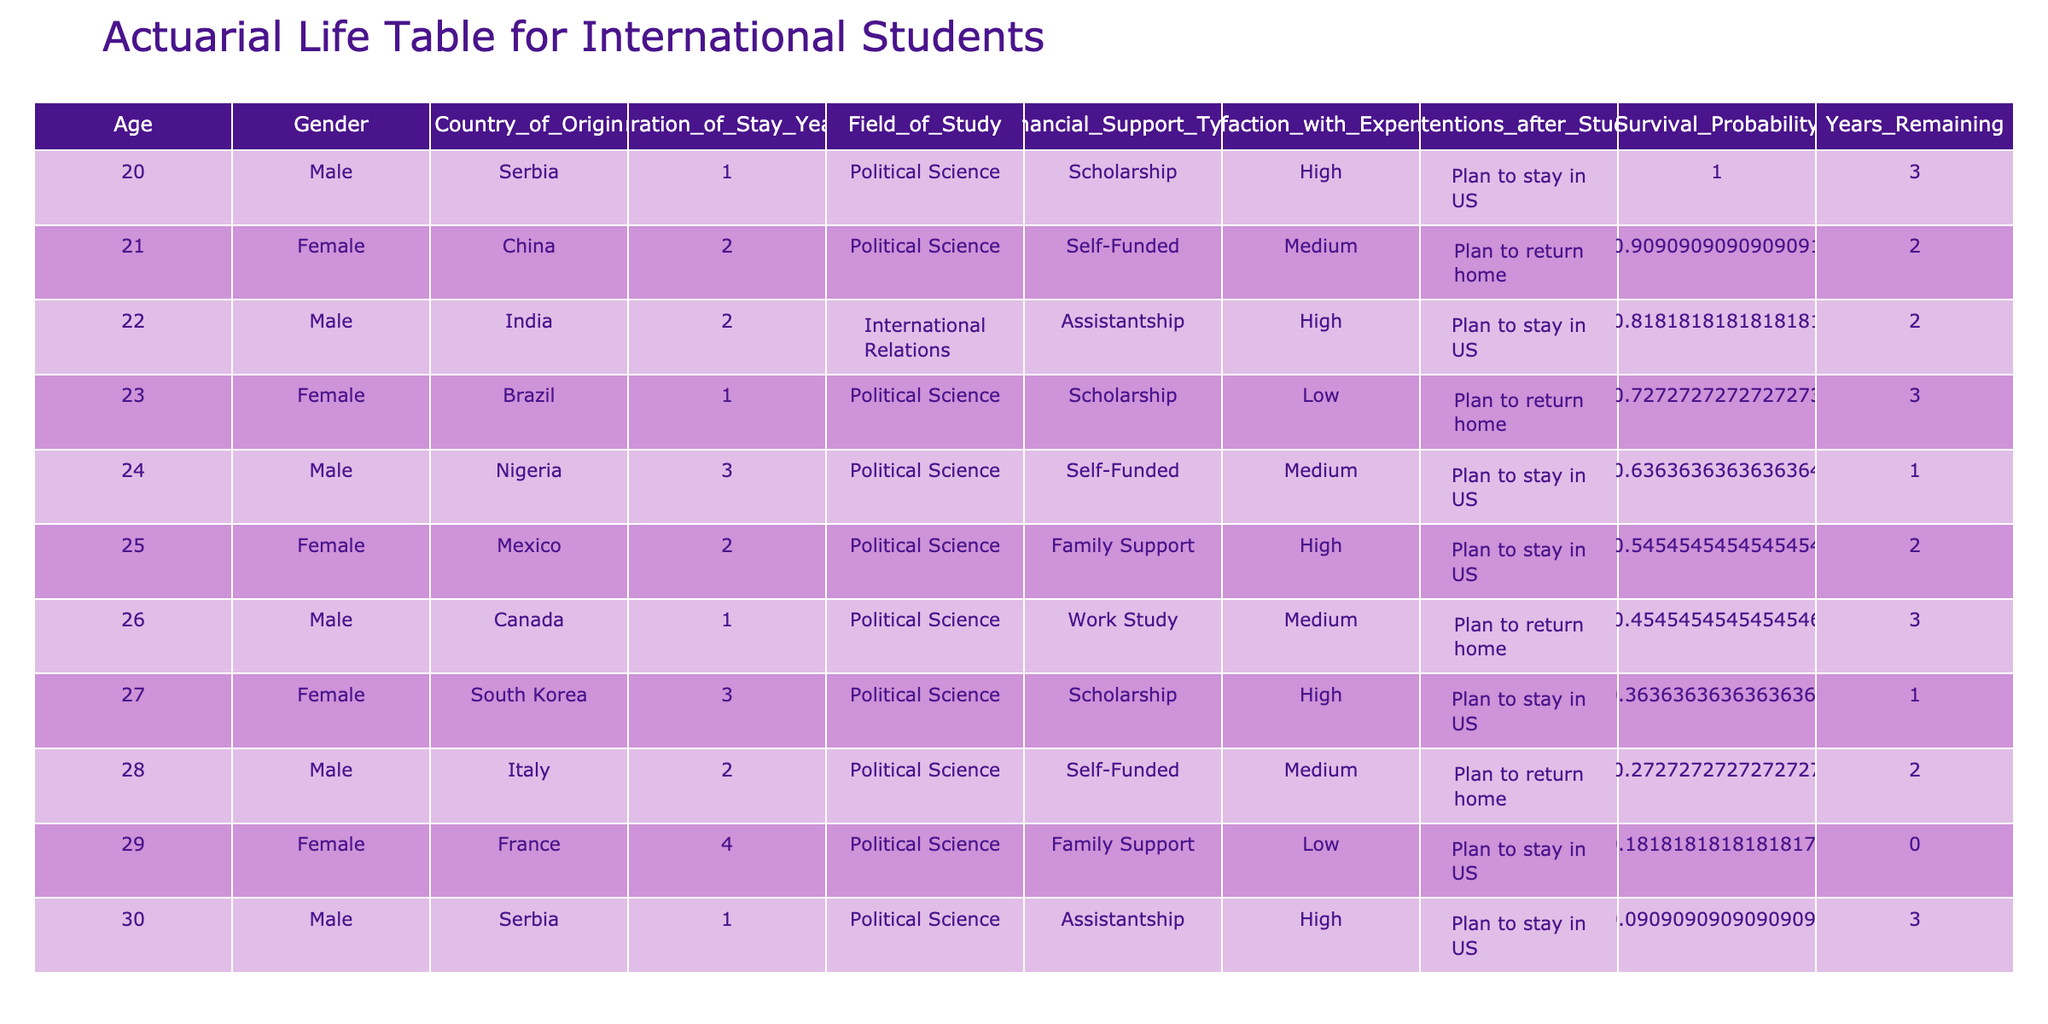What is the average duration of stay for the students from Nigeria? There is one entry for Nigeria with a duration of stay of 3 years. Thus, the average duration of stay for students from Nigeria is simply 3 years.
Answer: 3 years What is the gender of the student from France? The student from France is Female. This information can be found directly in the row corresponding to France.
Answer: Female Is there any student that has high satisfaction with their experience and plans to return home? Looking through the table, there are no students with high satisfaction and a plan to return home, as the only high satisfaction entries plan to stay in the US.
Answer: No How many students are from Self-Funded financial support type? By counting the entries, there are three students listed under Self-Funded: one from Nigeria, one from Italy, and one from China. Thus, the total is 3 students.
Answer: 3 students What is the difference between the maximum and minimum duration of stay years among all the students? The maximum duration of stay is 4 years (from France), and the minimum is 1 year (from Serbia, Canada, and Brazil). Therefore, the difference is 4 - 1 = 3 years.
Answer: 3 years Which country of origin has the highest number of students intending to stay in the US after their studies? The countries of Serbia, India, Brazil, South Korea, and France have students intending to stay, but Brazil has the highest number with two students (one in a low satisfaction category and one with high).
Answer: Brazil Are there any students in the Political Science field who are on a Family Support financial type? By examining the table, it shows that there are two Female students from Mexico and France who are on Family Support and are both in Political Science field.
Answer: Yes What is the survival probability of the Male student from Canada? The Male student from Canada is the sixth entry in the dataset. To calculate the survival probability, we use the formula: 1 - (index/total number of entries) = 1 - (5/10) = 0.5.
Answer: 0.5 